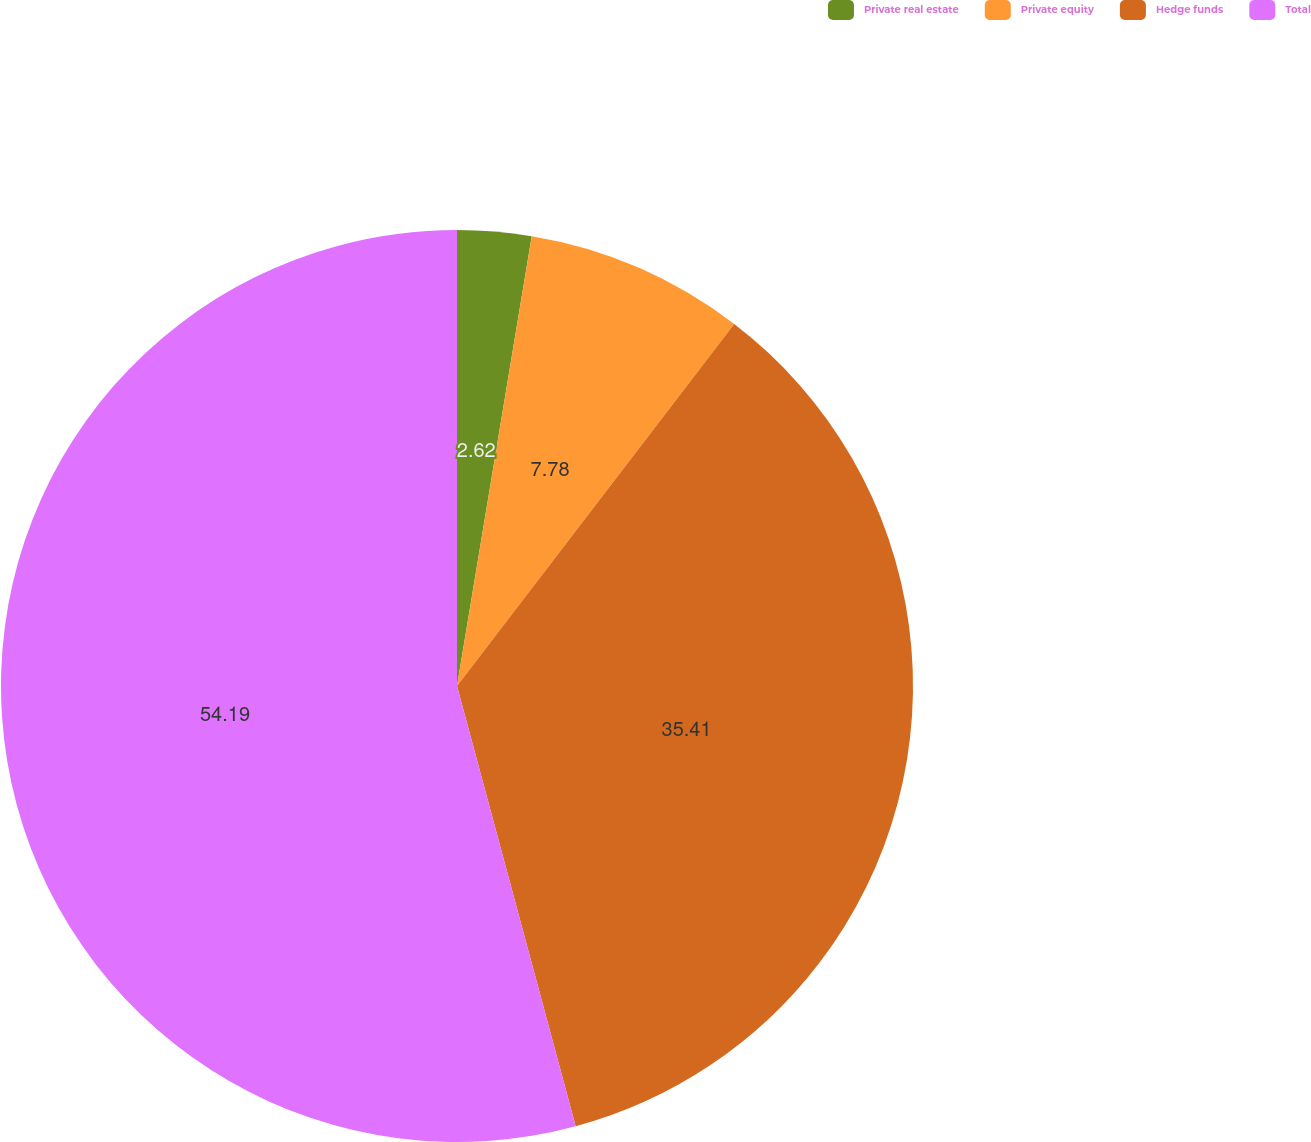<chart> <loc_0><loc_0><loc_500><loc_500><pie_chart><fcel>Private real estate<fcel>Private equity<fcel>Hedge funds<fcel>Total<nl><fcel>2.62%<fcel>7.78%<fcel>35.41%<fcel>54.19%<nl></chart> 